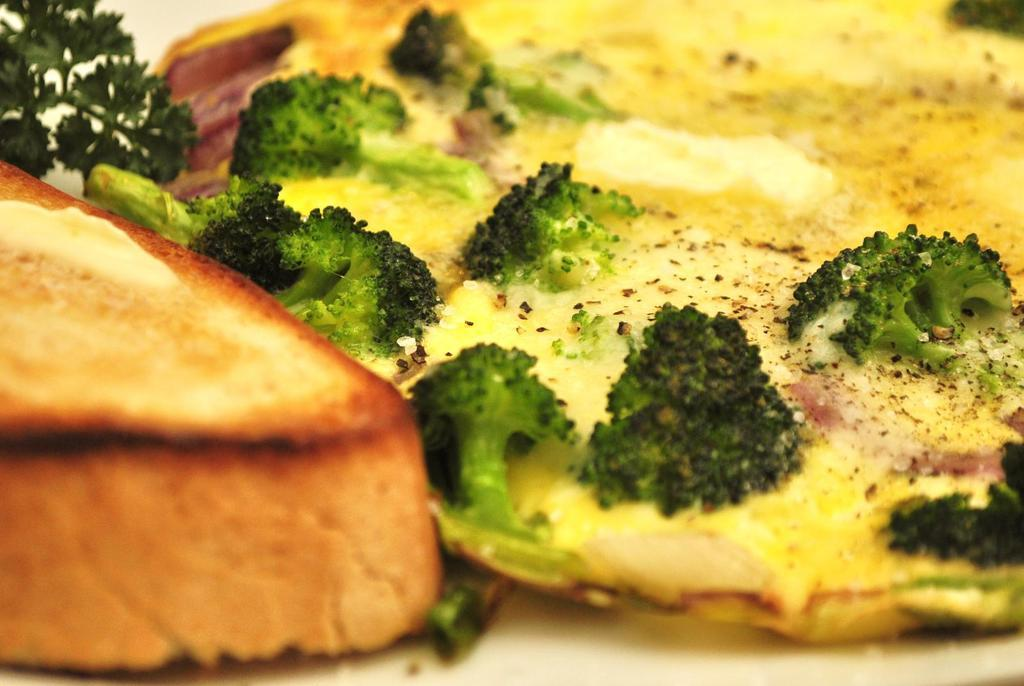What type of food is the main subject of the image? There is an omelet in the image. What other food items can be seen on the tray? There is bread, cabbage, and mint on the tray. How are these food items arranged in the image? All of these items are on a tray. What type of disease is affecting the cabbage in the image? There is no indication of any disease affecting the cabbage in the image; it appears to be a healthy vegetable. 